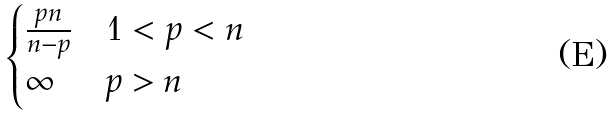<formula> <loc_0><loc_0><loc_500><loc_500>\begin{cases} \frac { p n } { n - p } & 1 < p < n \\ \infty & p > n \end{cases}</formula> 